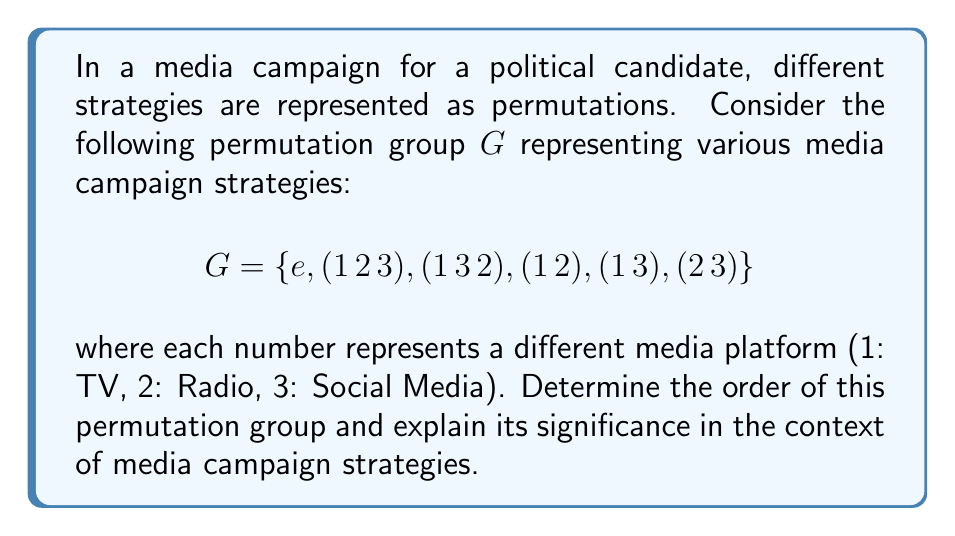Solve this math problem. To determine the order of the permutation group $G$, we need to count the number of distinct elements in the group. Let's break this down step-by-step:

1. First, let's identify each element:
   - $e$: the identity permutation (no change in strategy)
   - $(1\,2\,3)$: cyclic permutation (TV → Radio → Social Media → TV)
   - $(1\,3\,2)$: inverse of $(1\,2\,3)$ (TV → Social Media → Radio → TV)
   - $(1\,2)$: transposition (swaps TV and Radio)
   - $(1\,3)$: transposition (swaps TV and Social Media)
   - $(2\,3)$: transposition (swaps Radio and Social Media)

2. Count the number of elements: There are 6 distinct permutations in the group.

3. Therefore, the order of the group $G$ is 6.

In the context of media campaign strategies, this result signifies:

a) There are 6 different ways to arrange or prioritize the three media platforms (TV, Radio, Social Media) in the campaign.

b) The group structure suggests that any strategy can be transformed into any other strategy through a series of permutations.

c) The relatively small order of the group (6) implies that there are limited distinct ways to arrange these three platforms, which aligns with the persona's belief that campaign advertisements have limited influence on voter decision-making.

d) The presence of the identity element $e$ represents maintaining the current strategy, while other permutations represent various changes in platform prioritization.
Answer: The order of the permutation group $G$ is 6. 